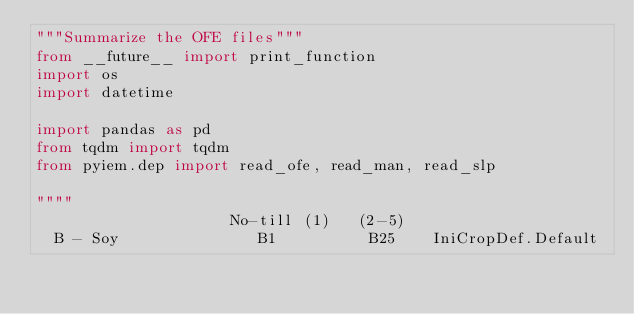<code> <loc_0><loc_0><loc_500><loc_500><_Python_>"""Summarize the OFE files"""
from __future__ import print_function
import os
import datetime

import pandas as pd
from tqdm import tqdm
from pyiem.dep import read_ofe, read_man, read_slp

""""
                     No-till (1)   (2-5)
  B - Soy               B1          B25    IniCropDef.Default</code> 